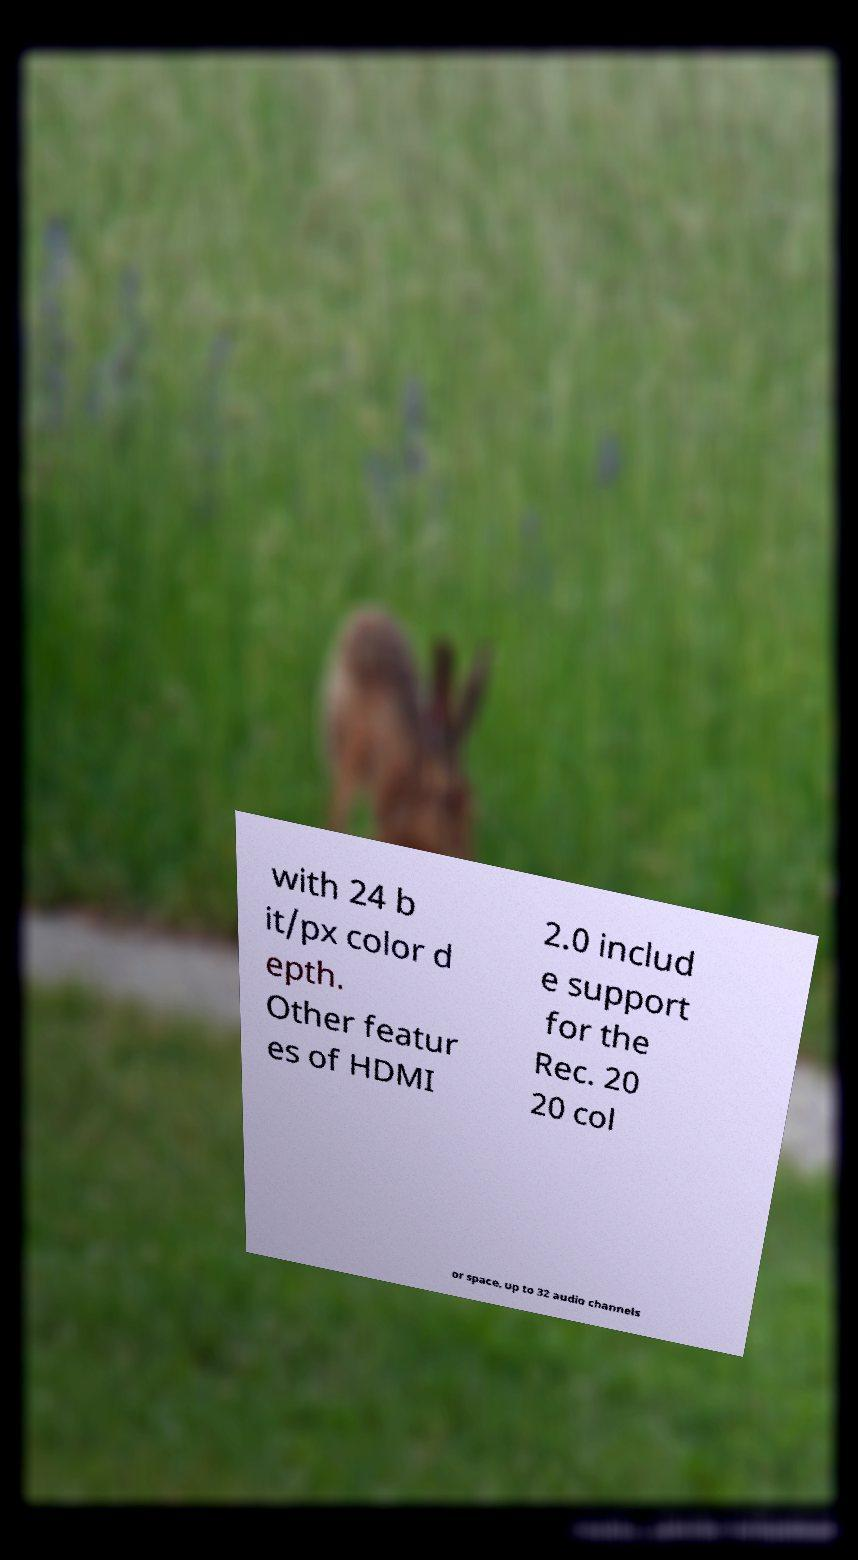Could you extract and type out the text from this image? with 24 b it/px color d epth. Other featur es of HDMI 2.0 includ e support for the Rec. 20 20 col or space, up to 32 audio channels 